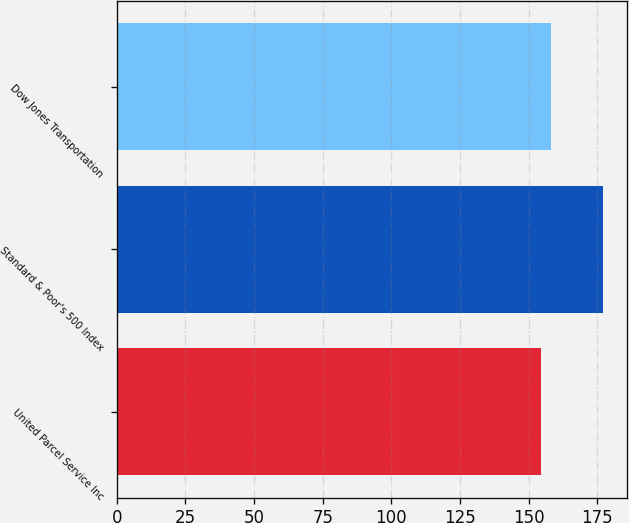<chart> <loc_0><loc_0><loc_500><loc_500><bar_chart><fcel>United Parcel Service Inc<fcel>Standard & Poor's 500 Index<fcel>Dow Jones Transportation<nl><fcel>154.61<fcel>176.94<fcel>158.22<nl></chart> 